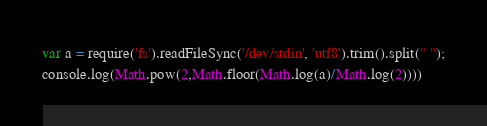Convert code to text. <code><loc_0><loc_0><loc_500><loc_500><_JavaScript_>var a = require('fs').readFileSync('/dev/stdin', 'utf8').trim().split(" ");
console.log(Math.pow(2,Math.floor(Math.log(a)/Math.log(2))))
</code> 